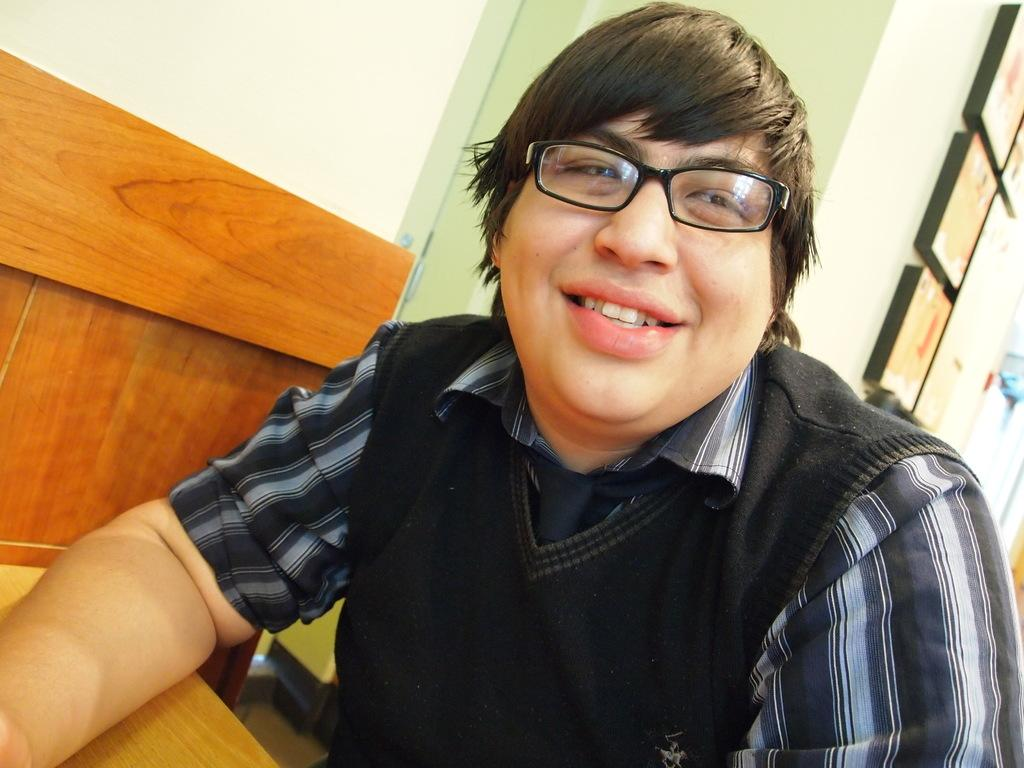What is the main subject of the image? There is a man in the image. What can be observed about the man's appearance? The man is wearing spectacles and smiling. What is in front of the man? There is a table in front of the man. What is visible behind the man? There is a wall visible in the image, and there are objects in the background. What type of crime is being committed in the image? There is no indication of a crime being committed in the image; it features a man smiling and wearing spectacles. How does the lock on the door in the image work? There is no door or lock present in the image. 